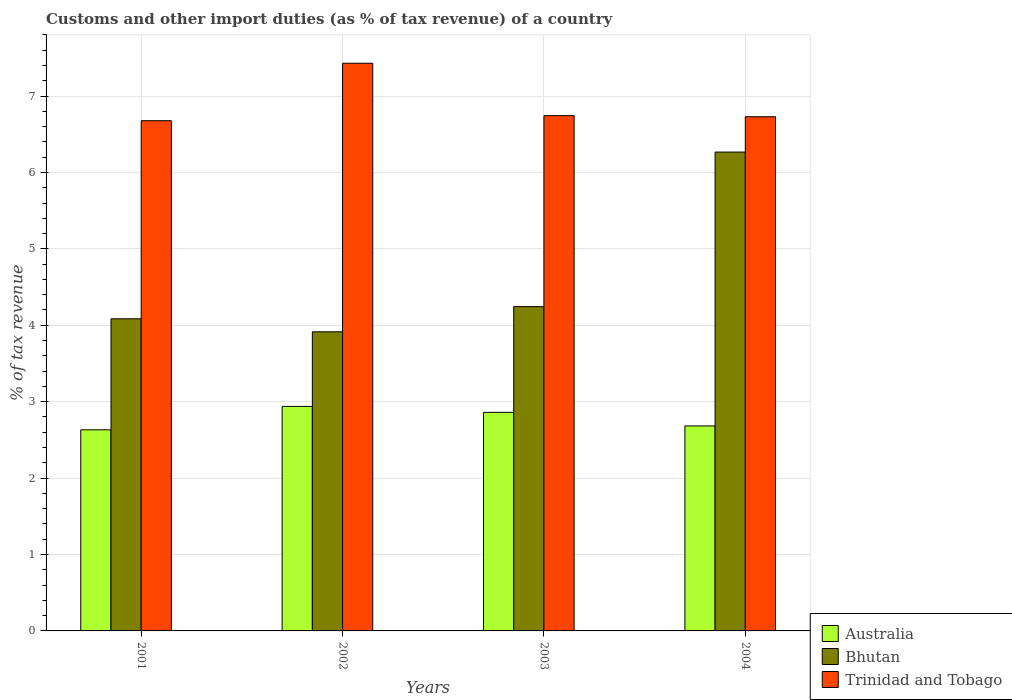How many different coloured bars are there?
Keep it short and to the point. 3. How many groups of bars are there?
Your response must be concise. 4. How many bars are there on the 3rd tick from the right?
Offer a very short reply. 3. In how many cases, is the number of bars for a given year not equal to the number of legend labels?
Keep it short and to the point. 0. What is the percentage of tax revenue from customs in Australia in 2004?
Provide a succinct answer. 2.68. Across all years, what is the maximum percentage of tax revenue from customs in Bhutan?
Give a very brief answer. 6.27. Across all years, what is the minimum percentage of tax revenue from customs in Trinidad and Tobago?
Provide a short and direct response. 6.68. In which year was the percentage of tax revenue from customs in Australia maximum?
Your response must be concise. 2002. What is the total percentage of tax revenue from customs in Australia in the graph?
Your response must be concise. 11.11. What is the difference between the percentage of tax revenue from customs in Australia in 2002 and that in 2004?
Keep it short and to the point. 0.26. What is the difference between the percentage of tax revenue from customs in Trinidad and Tobago in 2001 and the percentage of tax revenue from customs in Bhutan in 2004?
Provide a short and direct response. 0.41. What is the average percentage of tax revenue from customs in Bhutan per year?
Provide a short and direct response. 4.63. In the year 2004, what is the difference between the percentage of tax revenue from customs in Trinidad and Tobago and percentage of tax revenue from customs in Australia?
Your response must be concise. 4.05. What is the ratio of the percentage of tax revenue from customs in Bhutan in 2001 to that in 2003?
Provide a succinct answer. 0.96. What is the difference between the highest and the second highest percentage of tax revenue from customs in Bhutan?
Offer a terse response. 2.02. What is the difference between the highest and the lowest percentage of tax revenue from customs in Australia?
Your response must be concise. 0.31. Is the sum of the percentage of tax revenue from customs in Australia in 2003 and 2004 greater than the maximum percentage of tax revenue from customs in Bhutan across all years?
Keep it short and to the point. No. What does the 3rd bar from the left in 2003 represents?
Your answer should be compact. Trinidad and Tobago. What does the 3rd bar from the right in 2004 represents?
Offer a very short reply. Australia. How many years are there in the graph?
Your answer should be compact. 4. What is the difference between two consecutive major ticks on the Y-axis?
Offer a very short reply. 1. Are the values on the major ticks of Y-axis written in scientific E-notation?
Offer a very short reply. No. Does the graph contain grids?
Keep it short and to the point. Yes. Where does the legend appear in the graph?
Make the answer very short. Bottom right. How many legend labels are there?
Keep it short and to the point. 3. How are the legend labels stacked?
Give a very brief answer. Vertical. What is the title of the graph?
Your answer should be very brief. Customs and other import duties (as % of tax revenue) of a country. What is the label or title of the X-axis?
Your answer should be very brief. Years. What is the label or title of the Y-axis?
Give a very brief answer. % of tax revenue. What is the % of tax revenue of Australia in 2001?
Your answer should be very brief. 2.63. What is the % of tax revenue in Bhutan in 2001?
Your response must be concise. 4.08. What is the % of tax revenue of Trinidad and Tobago in 2001?
Keep it short and to the point. 6.68. What is the % of tax revenue in Australia in 2002?
Offer a very short reply. 2.94. What is the % of tax revenue of Bhutan in 2002?
Provide a succinct answer. 3.91. What is the % of tax revenue in Trinidad and Tobago in 2002?
Keep it short and to the point. 7.43. What is the % of tax revenue in Australia in 2003?
Make the answer very short. 2.86. What is the % of tax revenue in Bhutan in 2003?
Give a very brief answer. 4.24. What is the % of tax revenue of Trinidad and Tobago in 2003?
Give a very brief answer. 6.74. What is the % of tax revenue of Australia in 2004?
Ensure brevity in your answer.  2.68. What is the % of tax revenue of Bhutan in 2004?
Ensure brevity in your answer.  6.27. What is the % of tax revenue in Trinidad and Tobago in 2004?
Keep it short and to the point. 6.73. Across all years, what is the maximum % of tax revenue of Australia?
Make the answer very short. 2.94. Across all years, what is the maximum % of tax revenue of Bhutan?
Your answer should be compact. 6.27. Across all years, what is the maximum % of tax revenue in Trinidad and Tobago?
Offer a terse response. 7.43. Across all years, what is the minimum % of tax revenue of Australia?
Offer a very short reply. 2.63. Across all years, what is the minimum % of tax revenue in Bhutan?
Ensure brevity in your answer.  3.91. Across all years, what is the minimum % of tax revenue in Trinidad and Tobago?
Offer a terse response. 6.68. What is the total % of tax revenue of Australia in the graph?
Ensure brevity in your answer.  11.11. What is the total % of tax revenue of Bhutan in the graph?
Your answer should be very brief. 18.51. What is the total % of tax revenue of Trinidad and Tobago in the graph?
Your response must be concise. 27.58. What is the difference between the % of tax revenue of Australia in 2001 and that in 2002?
Provide a succinct answer. -0.31. What is the difference between the % of tax revenue of Bhutan in 2001 and that in 2002?
Ensure brevity in your answer.  0.17. What is the difference between the % of tax revenue in Trinidad and Tobago in 2001 and that in 2002?
Offer a terse response. -0.75. What is the difference between the % of tax revenue of Australia in 2001 and that in 2003?
Ensure brevity in your answer.  -0.23. What is the difference between the % of tax revenue of Bhutan in 2001 and that in 2003?
Offer a terse response. -0.16. What is the difference between the % of tax revenue of Trinidad and Tobago in 2001 and that in 2003?
Offer a terse response. -0.07. What is the difference between the % of tax revenue in Australia in 2001 and that in 2004?
Keep it short and to the point. -0.05. What is the difference between the % of tax revenue of Bhutan in 2001 and that in 2004?
Offer a very short reply. -2.18. What is the difference between the % of tax revenue in Trinidad and Tobago in 2001 and that in 2004?
Your answer should be compact. -0.05. What is the difference between the % of tax revenue in Australia in 2002 and that in 2003?
Your answer should be very brief. 0.08. What is the difference between the % of tax revenue in Bhutan in 2002 and that in 2003?
Ensure brevity in your answer.  -0.33. What is the difference between the % of tax revenue of Trinidad and Tobago in 2002 and that in 2003?
Offer a terse response. 0.69. What is the difference between the % of tax revenue of Australia in 2002 and that in 2004?
Your response must be concise. 0.26. What is the difference between the % of tax revenue of Bhutan in 2002 and that in 2004?
Your answer should be compact. -2.35. What is the difference between the % of tax revenue in Trinidad and Tobago in 2002 and that in 2004?
Ensure brevity in your answer.  0.7. What is the difference between the % of tax revenue of Australia in 2003 and that in 2004?
Provide a short and direct response. 0.18. What is the difference between the % of tax revenue of Bhutan in 2003 and that in 2004?
Ensure brevity in your answer.  -2.02. What is the difference between the % of tax revenue of Trinidad and Tobago in 2003 and that in 2004?
Offer a very short reply. 0.01. What is the difference between the % of tax revenue in Australia in 2001 and the % of tax revenue in Bhutan in 2002?
Provide a short and direct response. -1.28. What is the difference between the % of tax revenue in Australia in 2001 and the % of tax revenue in Trinidad and Tobago in 2002?
Keep it short and to the point. -4.8. What is the difference between the % of tax revenue in Bhutan in 2001 and the % of tax revenue in Trinidad and Tobago in 2002?
Your response must be concise. -3.34. What is the difference between the % of tax revenue in Australia in 2001 and the % of tax revenue in Bhutan in 2003?
Provide a short and direct response. -1.61. What is the difference between the % of tax revenue in Australia in 2001 and the % of tax revenue in Trinidad and Tobago in 2003?
Make the answer very short. -4.11. What is the difference between the % of tax revenue in Bhutan in 2001 and the % of tax revenue in Trinidad and Tobago in 2003?
Provide a succinct answer. -2.66. What is the difference between the % of tax revenue in Australia in 2001 and the % of tax revenue in Bhutan in 2004?
Your answer should be very brief. -3.63. What is the difference between the % of tax revenue of Australia in 2001 and the % of tax revenue of Trinidad and Tobago in 2004?
Offer a terse response. -4.1. What is the difference between the % of tax revenue in Bhutan in 2001 and the % of tax revenue in Trinidad and Tobago in 2004?
Ensure brevity in your answer.  -2.64. What is the difference between the % of tax revenue in Australia in 2002 and the % of tax revenue in Bhutan in 2003?
Make the answer very short. -1.31. What is the difference between the % of tax revenue in Australia in 2002 and the % of tax revenue in Trinidad and Tobago in 2003?
Your answer should be very brief. -3.81. What is the difference between the % of tax revenue of Bhutan in 2002 and the % of tax revenue of Trinidad and Tobago in 2003?
Keep it short and to the point. -2.83. What is the difference between the % of tax revenue of Australia in 2002 and the % of tax revenue of Bhutan in 2004?
Provide a short and direct response. -3.33. What is the difference between the % of tax revenue of Australia in 2002 and the % of tax revenue of Trinidad and Tobago in 2004?
Offer a terse response. -3.79. What is the difference between the % of tax revenue in Bhutan in 2002 and the % of tax revenue in Trinidad and Tobago in 2004?
Provide a short and direct response. -2.81. What is the difference between the % of tax revenue of Australia in 2003 and the % of tax revenue of Bhutan in 2004?
Give a very brief answer. -3.41. What is the difference between the % of tax revenue of Australia in 2003 and the % of tax revenue of Trinidad and Tobago in 2004?
Provide a succinct answer. -3.87. What is the difference between the % of tax revenue in Bhutan in 2003 and the % of tax revenue in Trinidad and Tobago in 2004?
Your answer should be compact. -2.49. What is the average % of tax revenue of Australia per year?
Ensure brevity in your answer.  2.78. What is the average % of tax revenue in Bhutan per year?
Offer a terse response. 4.63. What is the average % of tax revenue of Trinidad and Tobago per year?
Your response must be concise. 6.89. In the year 2001, what is the difference between the % of tax revenue in Australia and % of tax revenue in Bhutan?
Keep it short and to the point. -1.45. In the year 2001, what is the difference between the % of tax revenue of Australia and % of tax revenue of Trinidad and Tobago?
Offer a terse response. -4.05. In the year 2001, what is the difference between the % of tax revenue in Bhutan and % of tax revenue in Trinidad and Tobago?
Provide a succinct answer. -2.59. In the year 2002, what is the difference between the % of tax revenue in Australia and % of tax revenue in Bhutan?
Your answer should be compact. -0.98. In the year 2002, what is the difference between the % of tax revenue of Australia and % of tax revenue of Trinidad and Tobago?
Your answer should be compact. -4.49. In the year 2002, what is the difference between the % of tax revenue in Bhutan and % of tax revenue in Trinidad and Tobago?
Provide a short and direct response. -3.51. In the year 2003, what is the difference between the % of tax revenue in Australia and % of tax revenue in Bhutan?
Provide a short and direct response. -1.38. In the year 2003, what is the difference between the % of tax revenue in Australia and % of tax revenue in Trinidad and Tobago?
Provide a short and direct response. -3.88. In the year 2003, what is the difference between the % of tax revenue in Bhutan and % of tax revenue in Trinidad and Tobago?
Your answer should be very brief. -2.5. In the year 2004, what is the difference between the % of tax revenue of Australia and % of tax revenue of Bhutan?
Keep it short and to the point. -3.58. In the year 2004, what is the difference between the % of tax revenue in Australia and % of tax revenue in Trinidad and Tobago?
Offer a terse response. -4.05. In the year 2004, what is the difference between the % of tax revenue of Bhutan and % of tax revenue of Trinidad and Tobago?
Give a very brief answer. -0.46. What is the ratio of the % of tax revenue in Australia in 2001 to that in 2002?
Your response must be concise. 0.9. What is the ratio of the % of tax revenue of Bhutan in 2001 to that in 2002?
Your answer should be very brief. 1.04. What is the ratio of the % of tax revenue in Trinidad and Tobago in 2001 to that in 2002?
Your answer should be compact. 0.9. What is the ratio of the % of tax revenue of Australia in 2001 to that in 2003?
Give a very brief answer. 0.92. What is the ratio of the % of tax revenue of Bhutan in 2001 to that in 2003?
Keep it short and to the point. 0.96. What is the ratio of the % of tax revenue in Trinidad and Tobago in 2001 to that in 2003?
Your response must be concise. 0.99. What is the ratio of the % of tax revenue in Bhutan in 2001 to that in 2004?
Your response must be concise. 0.65. What is the ratio of the % of tax revenue in Australia in 2002 to that in 2003?
Make the answer very short. 1.03. What is the ratio of the % of tax revenue in Bhutan in 2002 to that in 2003?
Provide a short and direct response. 0.92. What is the ratio of the % of tax revenue in Trinidad and Tobago in 2002 to that in 2003?
Keep it short and to the point. 1.1. What is the ratio of the % of tax revenue of Australia in 2002 to that in 2004?
Give a very brief answer. 1.1. What is the ratio of the % of tax revenue of Bhutan in 2002 to that in 2004?
Ensure brevity in your answer.  0.62. What is the ratio of the % of tax revenue in Trinidad and Tobago in 2002 to that in 2004?
Keep it short and to the point. 1.1. What is the ratio of the % of tax revenue in Australia in 2003 to that in 2004?
Keep it short and to the point. 1.07. What is the ratio of the % of tax revenue in Bhutan in 2003 to that in 2004?
Your answer should be compact. 0.68. What is the difference between the highest and the second highest % of tax revenue in Australia?
Your response must be concise. 0.08. What is the difference between the highest and the second highest % of tax revenue of Bhutan?
Offer a terse response. 2.02. What is the difference between the highest and the second highest % of tax revenue in Trinidad and Tobago?
Your response must be concise. 0.69. What is the difference between the highest and the lowest % of tax revenue of Australia?
Offer a terse response. 0.31. What is the difference between the highest and the lowest % of tax revenue of Bhutan?
Ensure brevity in your answer.  2.35. What is the difference between the highest and the lowest % of tax revenue in Trinidad and Tobago?
Give a very brief answer. 0.75. 